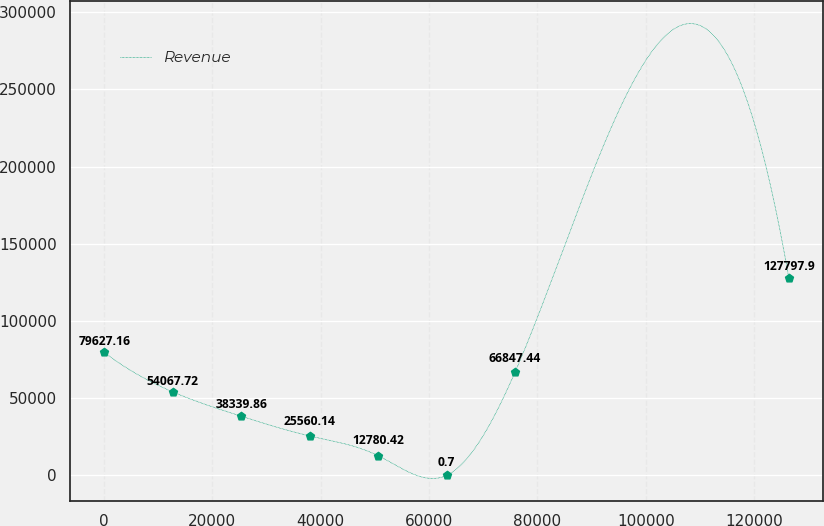Convert chart to OTSL. <chart><loc_0><loc_0><loc_500><loc_500><line_chart><ecel><fcel>Revenue<nl><fcel>75.32<fcel>79627.2<nl><fcel>12708.4<fcel>54067.7<nl><fcel>25341.4<fcel>38339.9<nl><fcel>37974.4<fcel>25560.1<nl><fcel>50607.4<fcel>12780.4<nl><fcel>63240.5<fcel>0.7<nl><fcel>75873.5<fcel>66847.4<nl><fcel>126406<fcel>127798<nl></chart> 